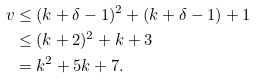<formula> <loc_0><loc_0><loc_500><loc_500>v & \leq ( k + \delta - 1 ) ^ { 2 } + ( k + \delta - 1 ) + 1 \\ & \leq ( k + 2 ) ^ { 2 } + k + 3 \\ & = k ^ { 2 } + 5 k + 7 .</formula> 